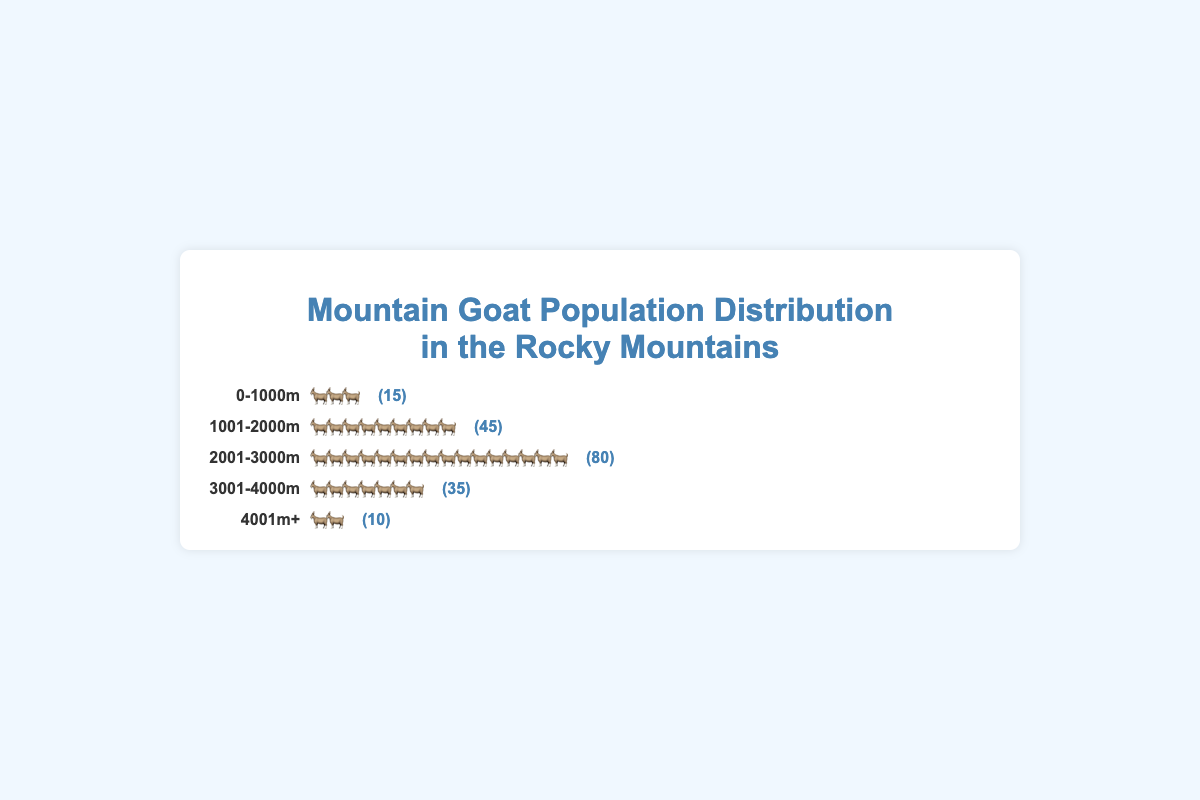What is the elevation range with the highest mountain goat population? To find the elevation range with the highest population, we compare the populations listed for each range. The elevation range 2001-3000m has the highest number of goats at 80.
Answer: 2001-3000m Which elevation range has the least mountain goat population? The elevation range with the least mountain goat population is the one with the smallest population number. The 4001m+ range has the smallest population, with only 10 goats.
Answer: 4001m+ How many mountain goats are there in the 1001-2000m range? The figure shows the population for each range. In the 1001-2000m range, there are 45 goats, which is clearly marked next to the icons.
Answer: 45 What is the total population of mountain goats across all elevations? To find the total population, we sum the populations of all elevation ranges: 15 (0-1000m) + 45 (1001-2000m) + 80 (2001-3000m) + 35 (3001-4000m) + 10 (4001m+). The total is 15 + 45 + 80 + 35 + 10 = 185.
Answer: 185 What is the difference in population between the 2001-3000m range and the 3001-4000m range? To find the difference, we subtract the population of the 3001-4000m range from the 2001-3000m range: 80 - 35. The difference is 45.
Answer: 45 What is the average population size across all elevation ranges? First, find the total population (185) and the number of ranges (5). The average population is calculated as 185 ÷ 5.
Answer: 37 Which elevation range has a population greater than 40 but less than 50? To determine which range meets the criteria, we look at the population numbers: 45 goats in the 1001-2000m range fits this condition.
Answer: 1001-2000m In which elevation range do we see 7 icons represent the population? Only the 3001-4000m range has 7 icons, representing a population of 35 goats considering each icon represents 5 goats.
Answer: 3001-4000m 